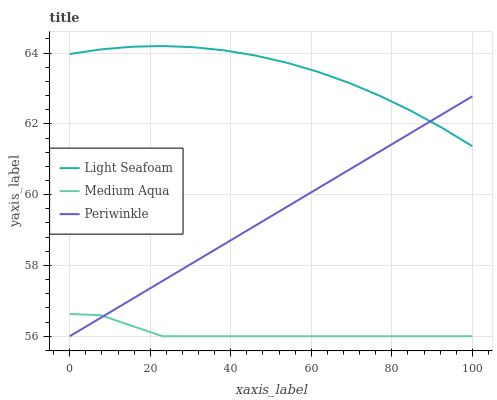Does Medium Aqua have the minimum area under the curve?
Answer yes or no. Yes. Does Light Seafoam have the maximum area under the curve?
Answer yes or no. Yes. Does Light Seafoam have the minimum area under the curve?
Answer yes or no. No. Does Medium Aqua have the maximum area under the curve?
Answer yes or no. No. Is Periwinkle the smoothest?
Answer yes or no. Yes. Is Light Seafoam the roughest?
Answer yes or no. Yes. Is Medium Aqua the smoothest?
Answer yes or no. No. Is Medium Aqua the roughest?
Answer yes or no. No. Does Periwinkle have the lowest value?
Answer yes or no. Yes. Does Light Seafoam have the lowest value?
Answer yes or no. No. Does Light Seafoam have the highest value?
Answer yes or no. Yes. Does Medium Aqua have the highest value?
Answer yes or no. No. Is Medium Aqua less than Light Seafoam?
Answer yes or no. Yes. Is Light Seafoam greater than Medium Aqua?
Answer yes or no. Yes. Does Periwinkle intersect Medium Aqua?
Answer yes or no. Yes. Is Periwinkle less than Medium Aqua?
Answer yes or no. No. Is Periwinkle greater than Medium Aqua?
Answer yes or no. No. Does Medium Aqua intersect Light Seafoam?
Answer yes or no. No. 